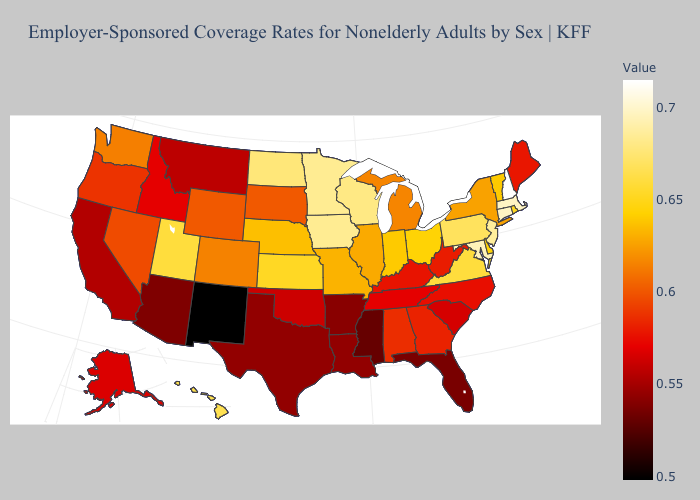Does the map have missing data?
Quick response, please. No. Among the states that border Wisconsin , which have the highest value?
Give a very brief answer. Iowa, Minnesota. Which states hav the highest value in the Northeast?
Quick response, please. New Hampshire. Does the map have missing data?
Keep it brief. No. Among the states that border North Dakota , which have the lowest value?
Short answer required. Montana. Does New Mexico have the lowest value in the West?
Answer briefly. Yes. 